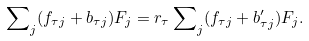<formula> <loc_0><loc_0><loc_500><loc_500>\sum \nolimits _ { j } ( f _ { \tau j } + b _ { \tau j } ) F _ { j } = r _ { \tau } \sum \nolimits _ { j } ( f _ { \tau j } + b _ { \tau j } ^ { \prime } ) F _ { j } .</formula> 